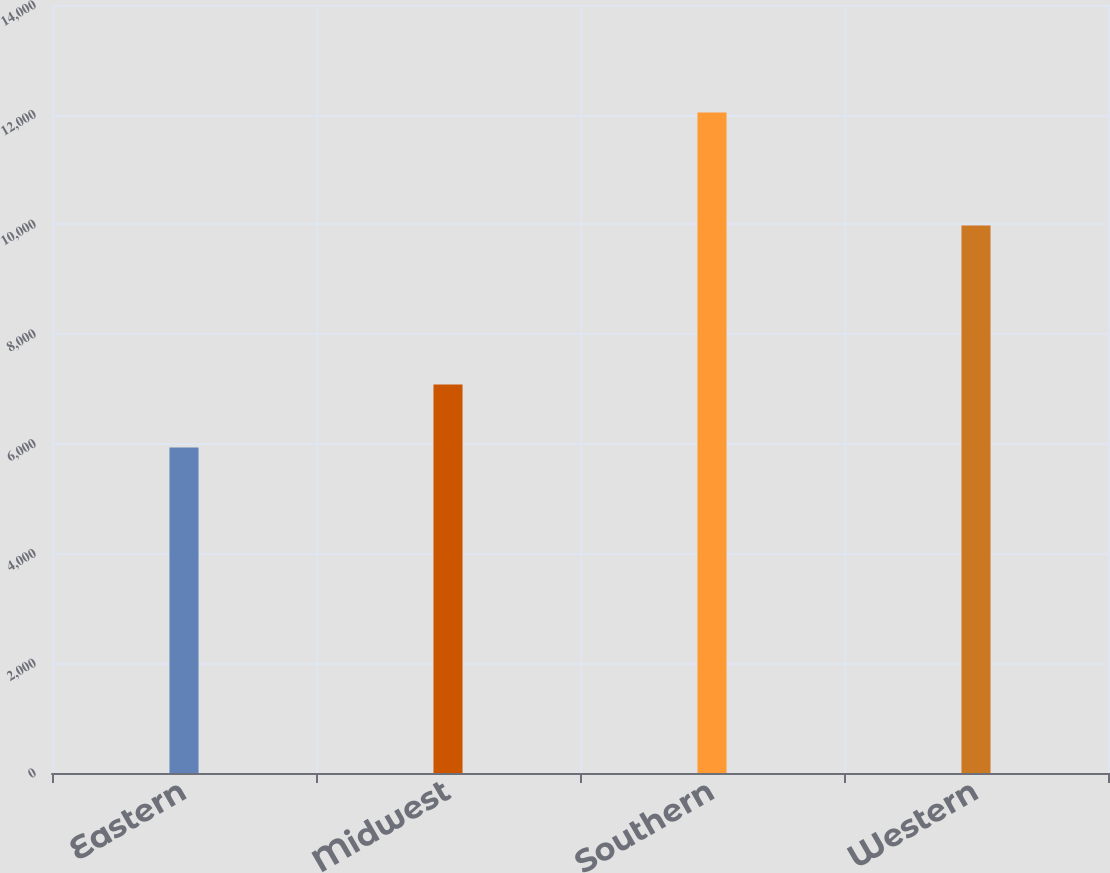<chart> <loc_0><loc_0><loc_500><loc_500><bar_chart><fcel>Eastern<fcel>Midwest<fcel>Southern<fcel>Western<nl><fcel>5934<fcel>7081<fcel>12039<fcel>9981<nl></chart> 